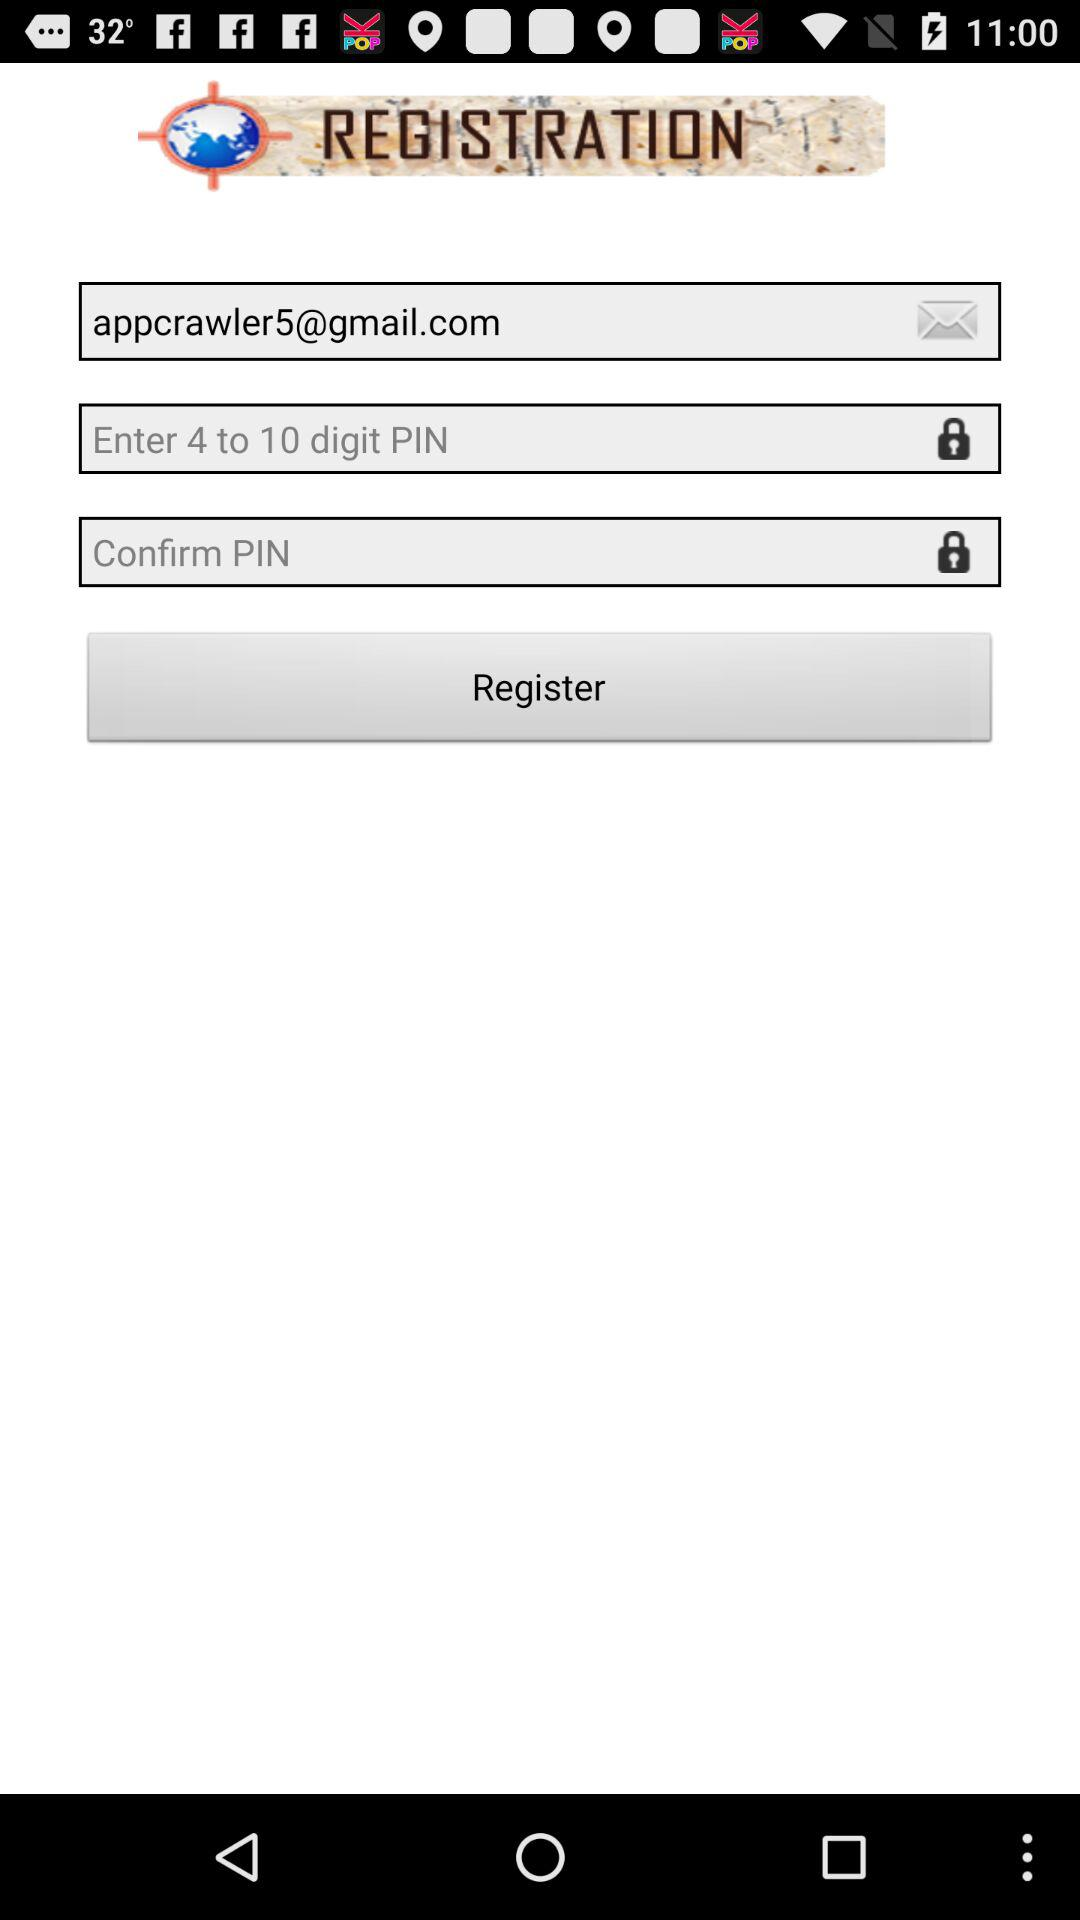What can the length of the PIN be? The length of the PIN can be from 4 to 10 digits. 